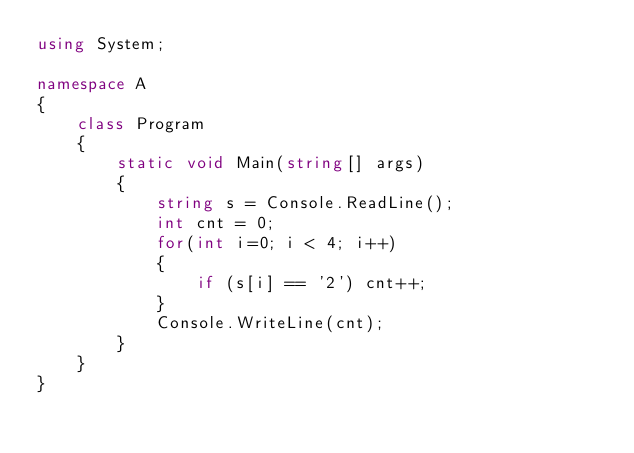Convert code to text. <code><loc_0><loc_0><loc_500><loc_500><_C#_>using System;

namespace A
{
    class Program
    {
        static void Main(string[] args)
        {
            string s = Console.ReadLine();
            int cnt = 0;
            for(int i=0; i < 4; i++)
            {
                if (s[i] == '2') cnt++;
            }
            Console.WriteLine(cnt);
        }
    }
}
</code> 